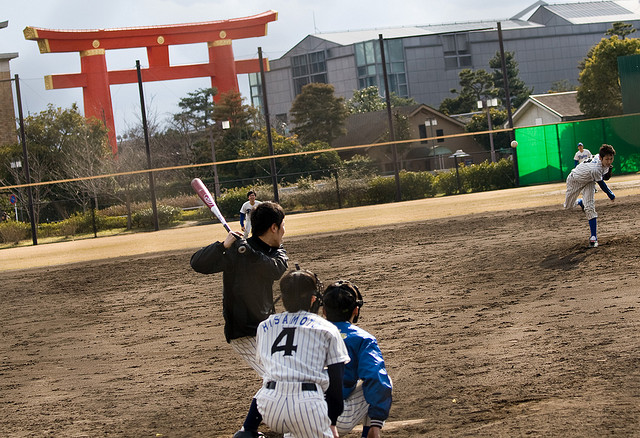Read and extract the text from this image. 4 HISOMOT 